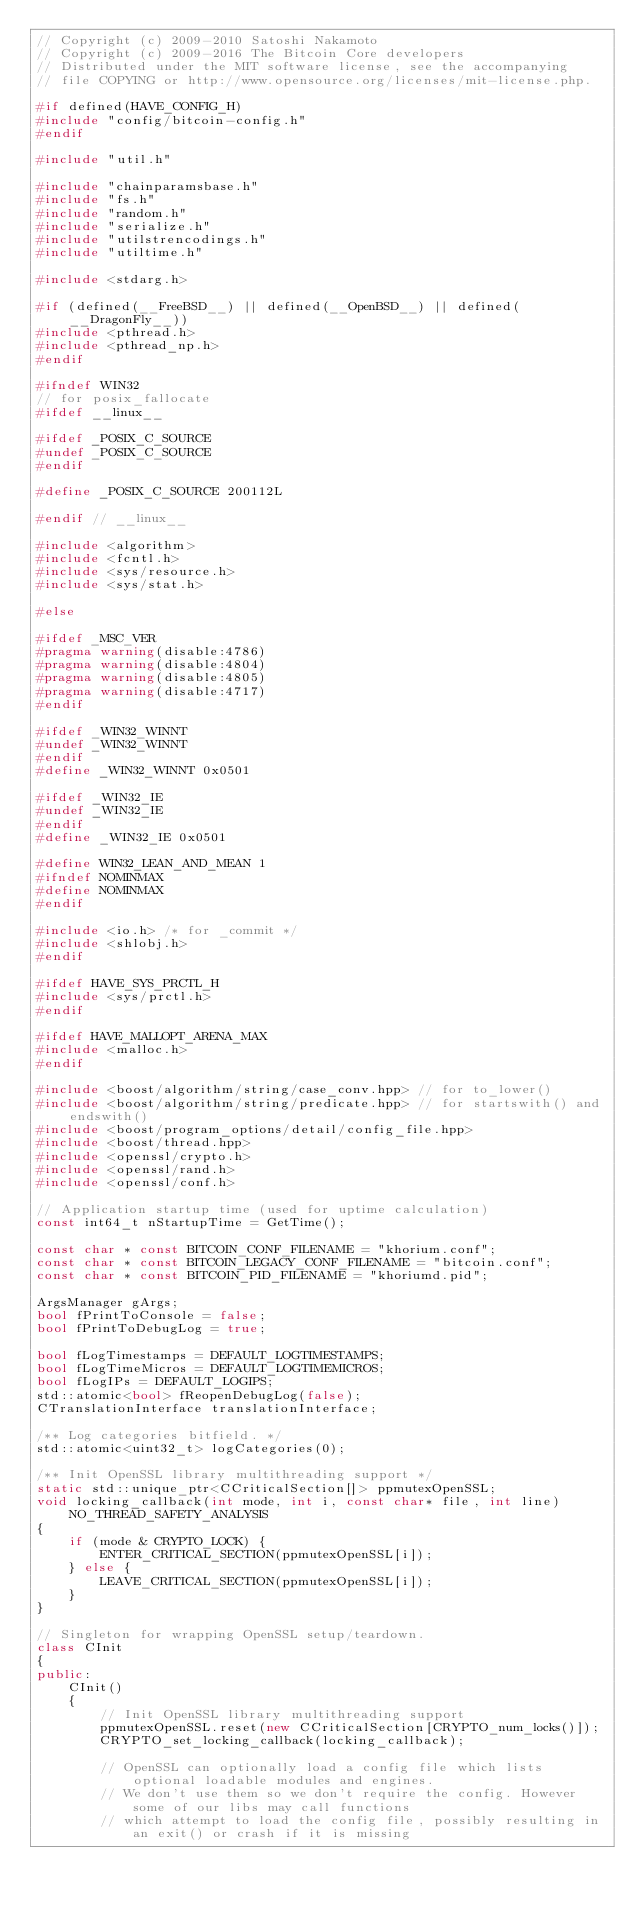Convert code to text. <code><loc_0><loc_0><loc_500><loc_500><_C++_>// Copyright (c) 2009-2010 Satoshi Nakamoto
// Copyright (c) 2009-2016 The Bitcoin Core developers
// Distributed under the MIT software license, see the accompanying
// file COPYING or http://www.opensource.org/licenses/mit-license.php.

#if defined(HAVE_CONFIG_H)
#include "config/bitcoin-config.h"
#endif

#include "util.h"

#include "chainparamsbase.h"
#include "fs.h"
#include "random.h"
#include "serialize.h"
#include "utilstrencodings.h"
#include "utiltime.h"

#include <stdarg.h>

#if (defined(__FreeBSD__) || defined(__OpenBSD__) || defined(__DragonFly__))
#include <pthread.h>
#include <pthread_np.h>
#endif

#ifndef WIN32
// for posix_fallocate
#ifdef __linux__

#ifdef _POSIX_C_SOURCE
#undef _POSIX_C_SOURCE
#endif

#define _POSIX_C_SOURCE 200112L

#endif // __linux__

#include <algorithm>
#include <fcntl.h>
#include <sys/resource.h>
#include <sys/stat.h>

#else

#ifdef _MSC_VER
#pragma warning(disable:4786)
#pragma warning(disable:4804)
#pragma warning(disable:4805)
#pragma warning(disable:4717)
#endif

#ifdef _WIN32_WINNT
#undef _WIN32_WINNT
#endif
#define _WIN32_WINNT 0x0501

#ifdef _WIN32_IE
#undef _WIN32_IE
#endif
#define _WIN32_IE 0x0501

#define WIN32_LEAN_AND_MEAN 1
#ifndef NOMINMAX
#define NOMINMAX
#endif

#include <io.h> /* for _commit */
#include <shlobj.h>
#endif

#ifdef HAVE_SYS_PRCTL_H
#include <sys/prctl.h>
#endif

#ifdef HAVE_MALLOPT_ARENA_MAX
#include <malloc.h>
#endif

#include <boost/algorithm/string/case_conv.hpp> // for to_lower()
#include <boost/algorithm/string/predicate.hpp> // for startswith() and endswith()
#include <boost/program_options/detail/config_file.hpp>
#include <boost/thread.hpp>
#include <openssl/crypto.h>
#include <openssl/rand.h>
#include <openssl/conf.h>

// Application startup time (used for uptime calculation)
const int64_t nStartupTime = GetTime();

const char * const BITCOIN_CONF_FILENAME = "khorium.conf";
const char * const BITCOIN_LEGACY_CONF_FILENAME = "bitcoin.conf";
const char * const BITCOIN_PID_FILENAME = "khoriumd.pid";

ArgsManager gArgs;
bool fPrintToConsole = false;
bool fPrintToDebugLog = true;

bool fLogTimestamps = DEFAULT_LOGTIMESTAMPS;
bool fLogTimeMicros = DEFAULT_LOGTIMEMICROS;
bool fLogIPs = DEFAULT_LOGIPS;
std::atomic<bool> fReopenDebugLog(false);
CTranslationInterface translationInterface;

/** Log categories bitfield. */
std::atomic<uint32_t> logCategories(0);

/** Init OpenSSL library multithreading support */
static std::unique_ptr<CCriticalSection[]> ppmutexOpenSSL;
void locking_callback(int mode, int i, const char* file, int line) NO_THREAD_SAFETY_ANALYSIS
{
    if (mode & CRYPTO_LOCK) {
        ENTER_CRITICAL_SECTION(ppmutexOpenSSL[i]);
    } else {
        LEAVE_CRITICAL_SECTION(ppmutexOpenSSL[i]);
    }
}

// Singleton for wrapping OpenSSL setup/teardown.
class CInit
{
public:
    CInit()
    {
        // Init OpenSSL library multithreading support
        ppmutexOpenSSL.reset(new CCriticalSection[CRYPTO_num_locks()]);
        CRYPTO_set_locking_callback(locking_callback);

        // OpenSSL can optionally load a config file which lists optional loadable modules and engines.
        // We don't use them so we don't require the config. However some of our libs may call functions
        // which attempt to load the config file, possibly resulting in an exit() or crash if it is missing</code> 